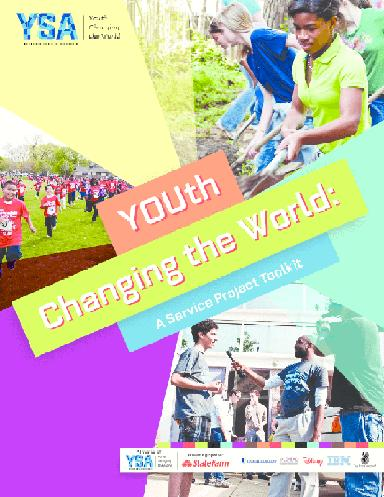What is the main message on the brochure?
 The main message on the brochure is "Youth Changing the World". What organization is associated with this message? The organization associated with this message is YSA. 